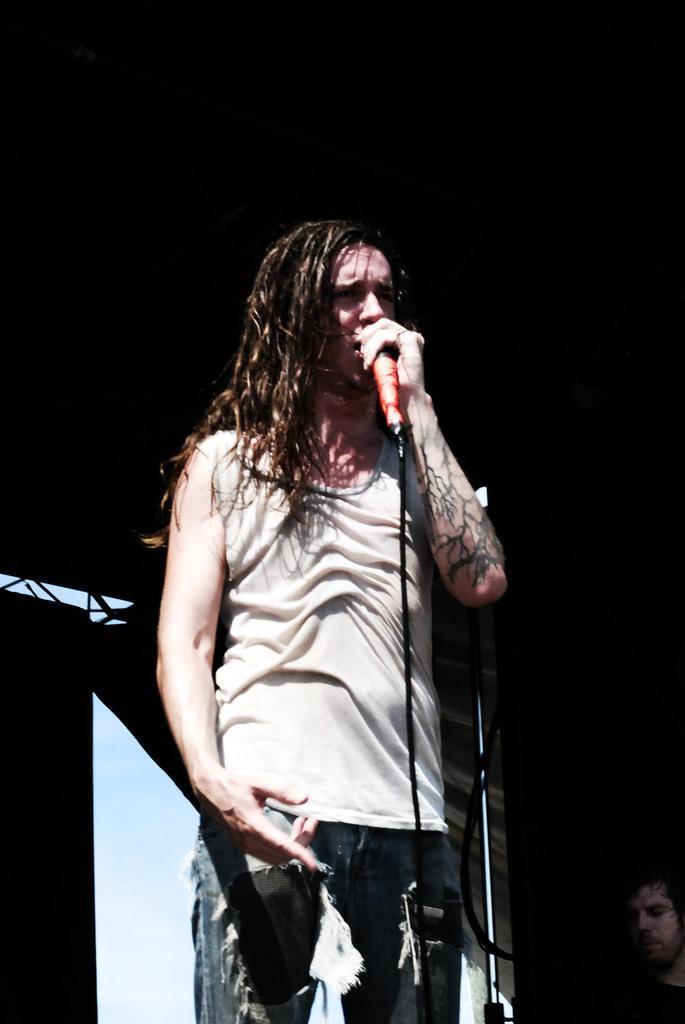How would you summarize this image in a sentence or two? A beautiful girl is standing and singing, she wore t-shirt, trouser. 